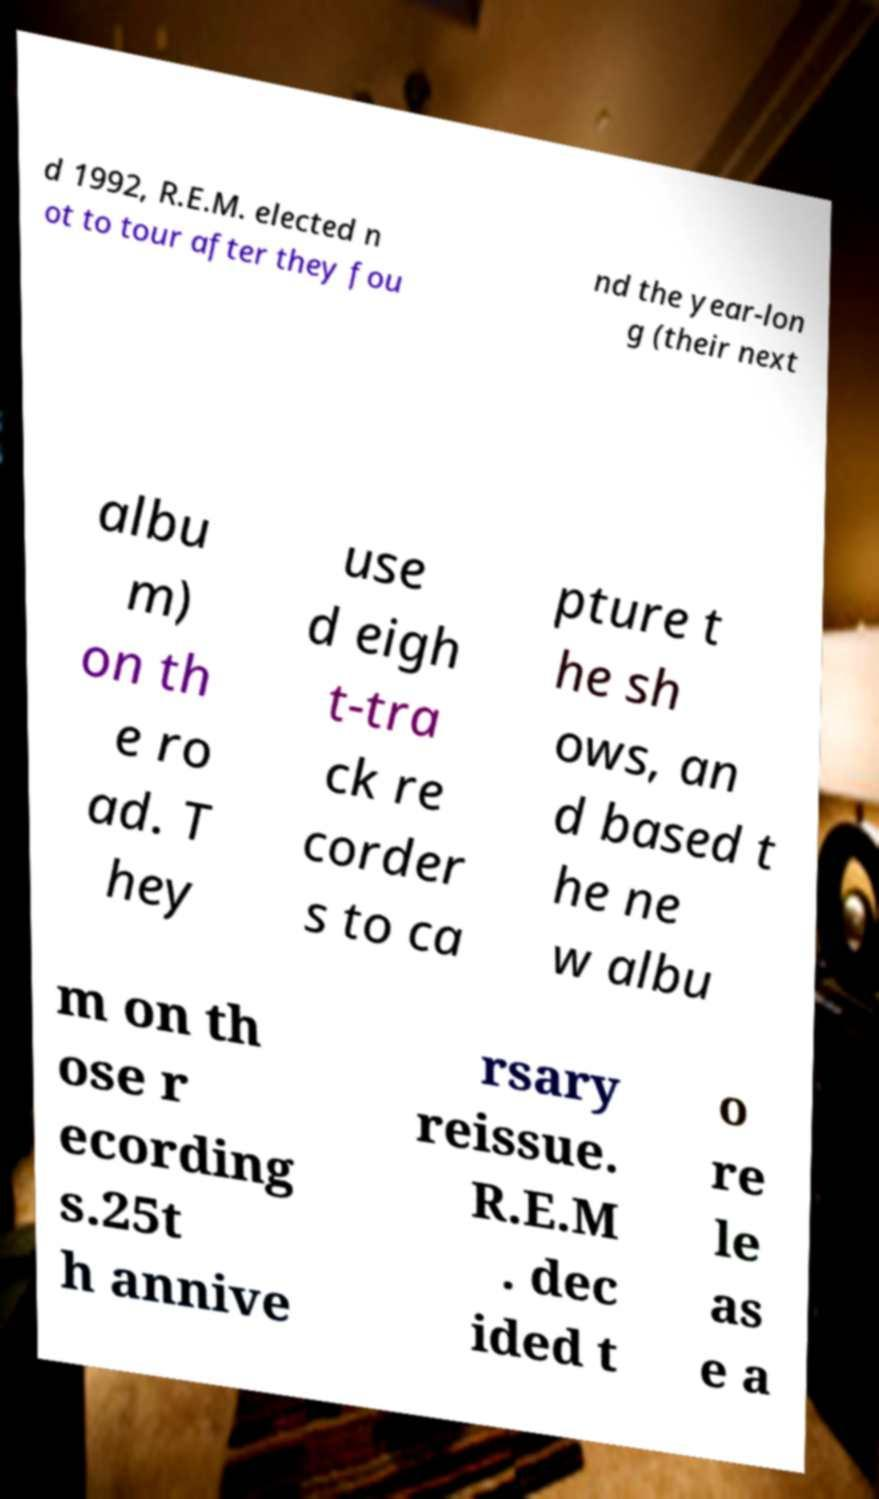What messages or text are displayed in this image? I need them in a readable, typed format. d 1992, R.E.M. elected n ot to tour after they fou nd the year-lon g (their next albu m) on th e ro ad. T hey use d eigh t-tra ck re corder s to ca pture t he sh ows, an d based t he ne w albu m on th ose r ecording s.25t h annive rsary reissue. R.E.M . dec ided t o re le as e a 